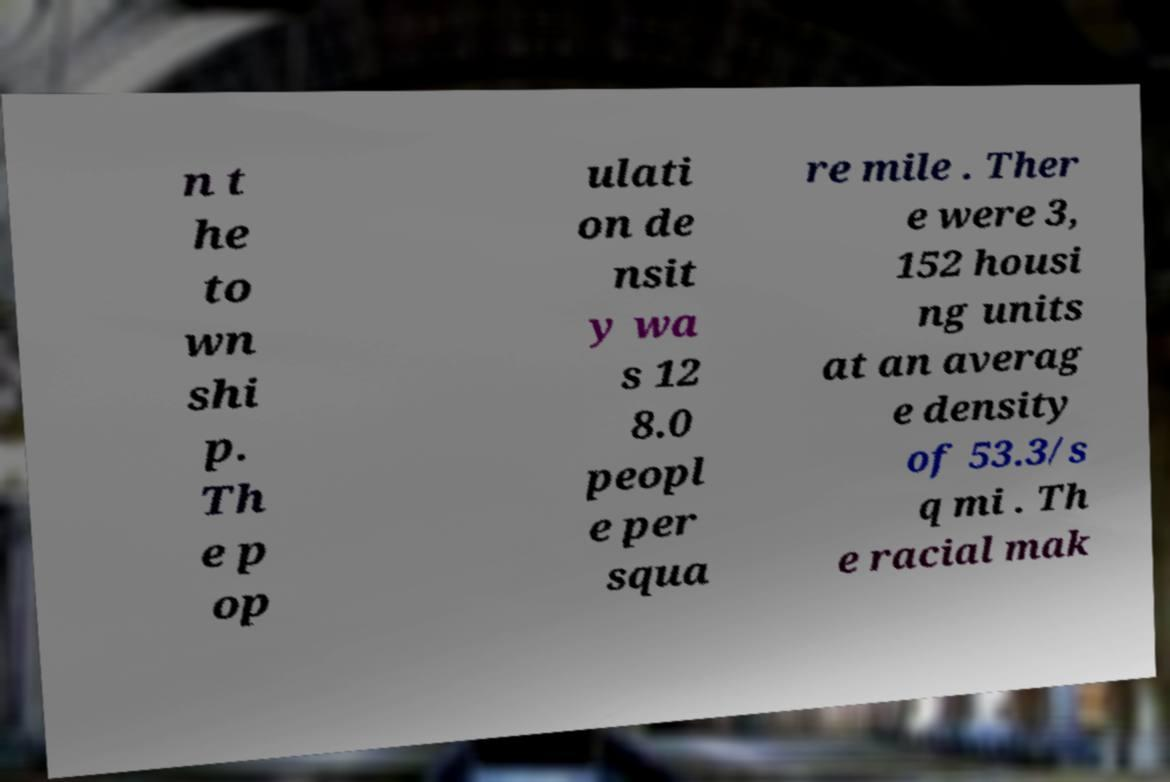There's text embedded in this image that I need extracted. Can you transcribe it verbatim? n t he to wn shi p. Th e p op ulati on de nsit y wa s 12 8.0 peopl e per squa re mile . Ther e were 3, 152 housi ng units at an averag e density of 53.3/s q mi . Th e racial mak 